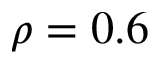Convert formula to latex. <formula><loc_0><loc_0><loc_500><loc_500>\rho = 0 . 6</formula> 